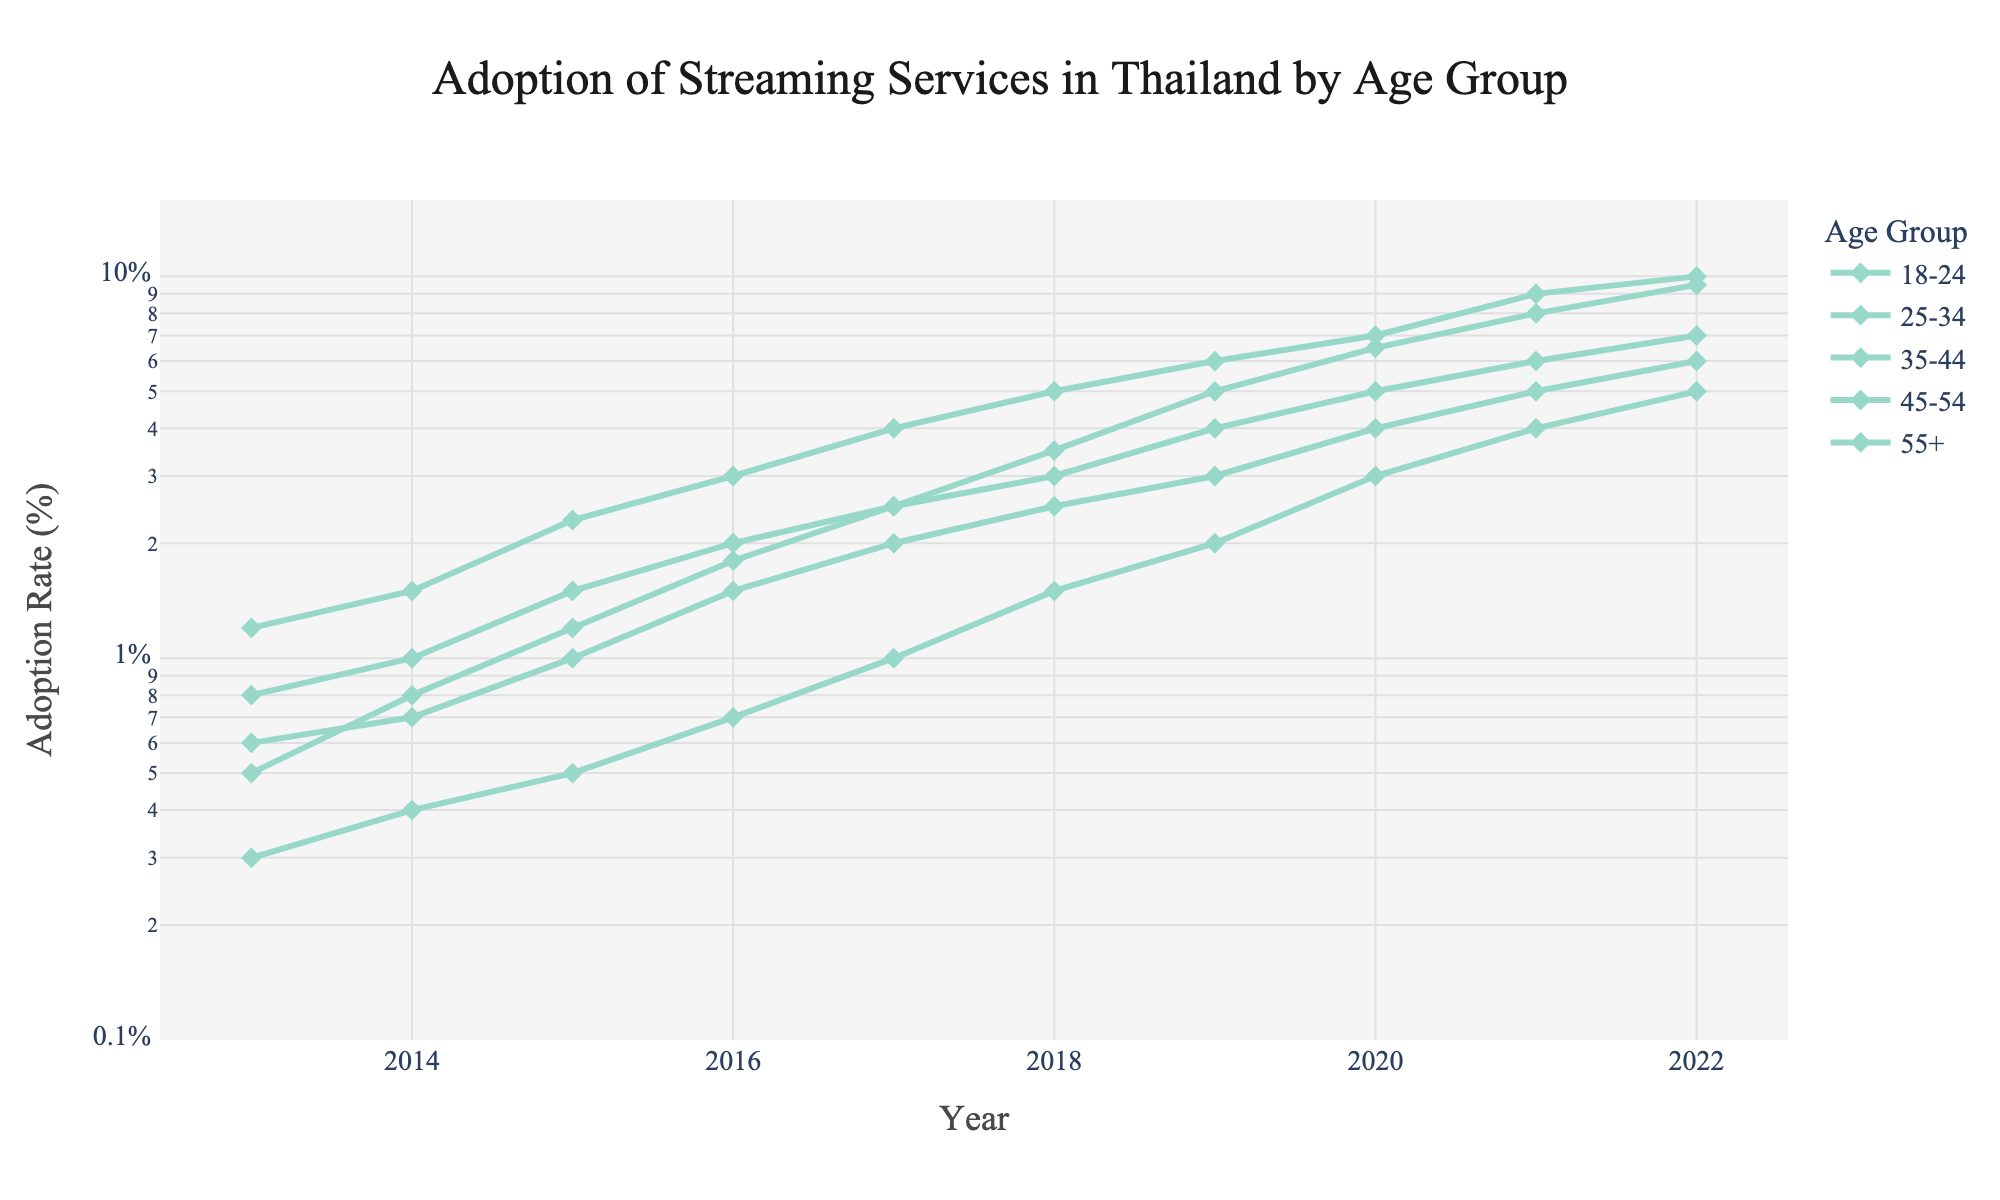What is the adoption rate for the 18-24 age group in 2022? Look for the year 2022 on the x-axis and find the point corresponding to the 18-24 age group on the plot. The y-axis shows the rate on a log scale.
Answer: 9.5% Which age group had the highest adoption rate in 2020? Locate the year 2020 on the x-axis and compare the y-values of all age groups for that year. The one with the highest y-value on the log scale is the highest.
Answer: 25-34 How did the adoption rate for the 55+ age group change from 2013 to 2022? Find the points for the 55+ age group in 2013 and 2022. Observe the increase in y-value on the log scale from these years.
Answer: Increased from 0.3% to 5% Which age group saw the biggest increase in adoption rate between 2014 and 2015? Compare the y-values for each age group between 2014 and 2015. Calculate the difference to find the largest increase.
Answer: 25-34 What is the general trend in adoption rates for the 35-44 age group over the decade? Observe the line representing the 35-44 age group. Note the general direction and slope of the line over the years.
Answer: Increasing During which year did the 45-54 age group reach an adoption rate of 5%? Find the point on the plot where the line for the 45-54 age group intersects with 5% on the y-axis.
Answer: 2021 Is there any age group that had a decrease in adoption rate at any point during the decade? Check each line to see if there is any point where the y-value decreases compared to the previous year.
Answer: No Which two age groups had the closest adoption rates in 2017? Compare the y-values for each age group in 2017. Identify the two groups whose y-values are closest on the plot.
Answer: 35-44 and 45-54 